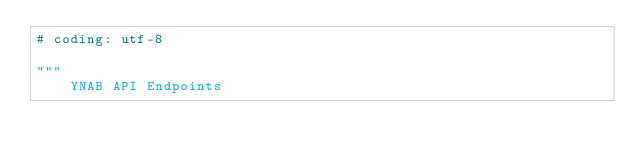Convert code to text. <code><loc_0><loc_0><loc_500><loc_500><_Python_># coding: utf-8

"""
    YNAB API Endpoints
</code> 